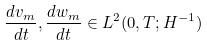Convert formula to latex. <formula><loc_0><loc_0><loc_500><loc_500>\frac { d v _ { m } } { d t } , \frac { d w _ { m } } { d t } \in L ^ { 2 } ( 0 , T ; H ^ { - 1 } )</formula> 